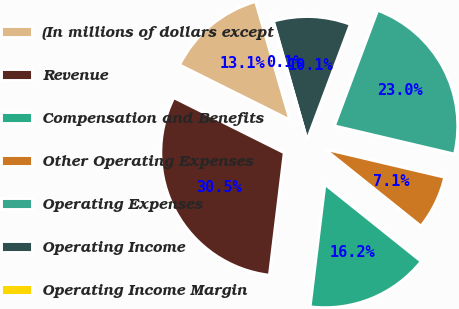<chart> <loc_0><loc_0><loc_500><loc_500><pie_chart><fcel>(In millions of dollars except<fcel>Revenue<fcel>Compensation and Benefits<fcel>Other Operating Expenses<fcel>Operating Expenses<fcel>Operating Income<fcel>Operating Income Margin<nl><fcel>13.14%<fcel>30.45%<fcel>16.17%<fcel>7.07%<fcel>22.97%<fcel>10.1%<fcel>0.1%<nl></chart> 